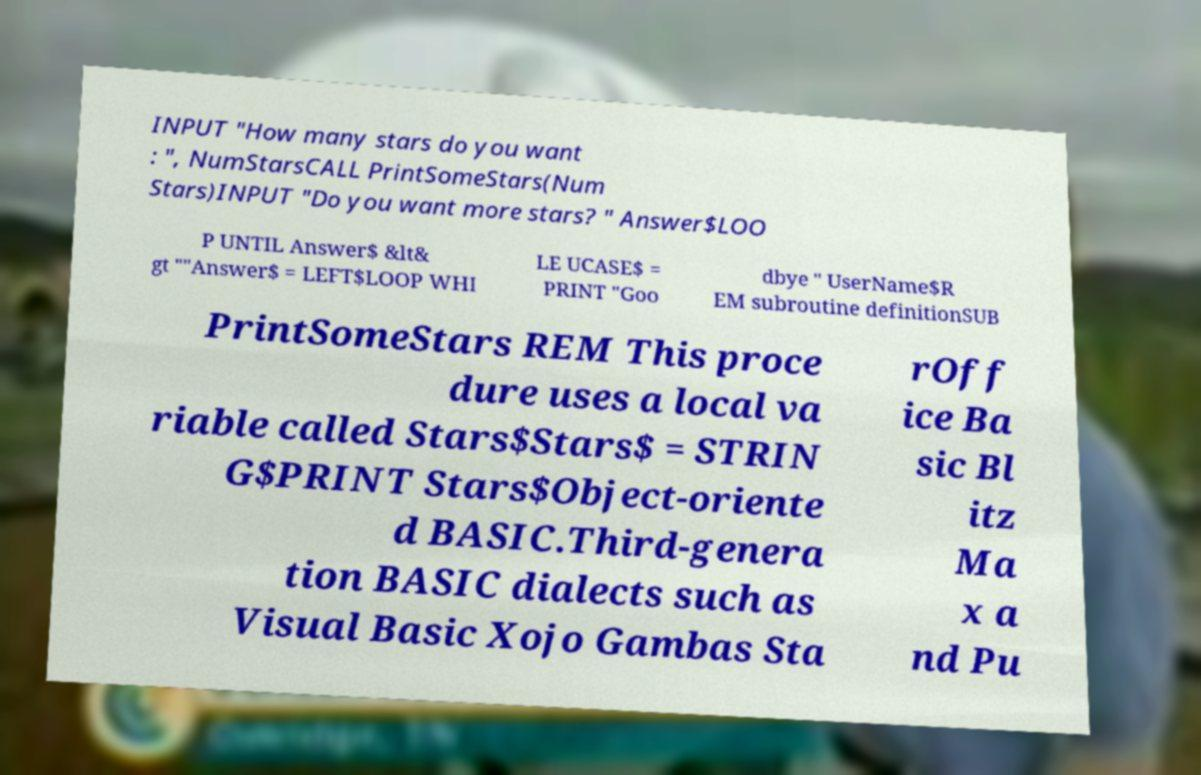Could you assist in decoding the text presented in this image and type it out clearly? INPUT "How many stars do you want : ", NumStarsCALL PrintSomeStars(Num Stars)INPUT "Do you want more stars? " Answer$LOO P UNTIL Answer$ &lt& gt ""Answer$ = LEFT$LOOP WHI LE UCASE$ = PRINT "Goo dbye " UserName$R EM subroutine definitionSUB PrintSomeStars REM This proce dure uses a local va riable called Stars$Stars$ = STRIN G$PRINT Stars$Object-oriente d BASIC.Third-genera tion BASIC dialects such as Visual Basic Xojo Gambas Sta rOff ice Ba sic Bl itz Ma x a nd Pu 